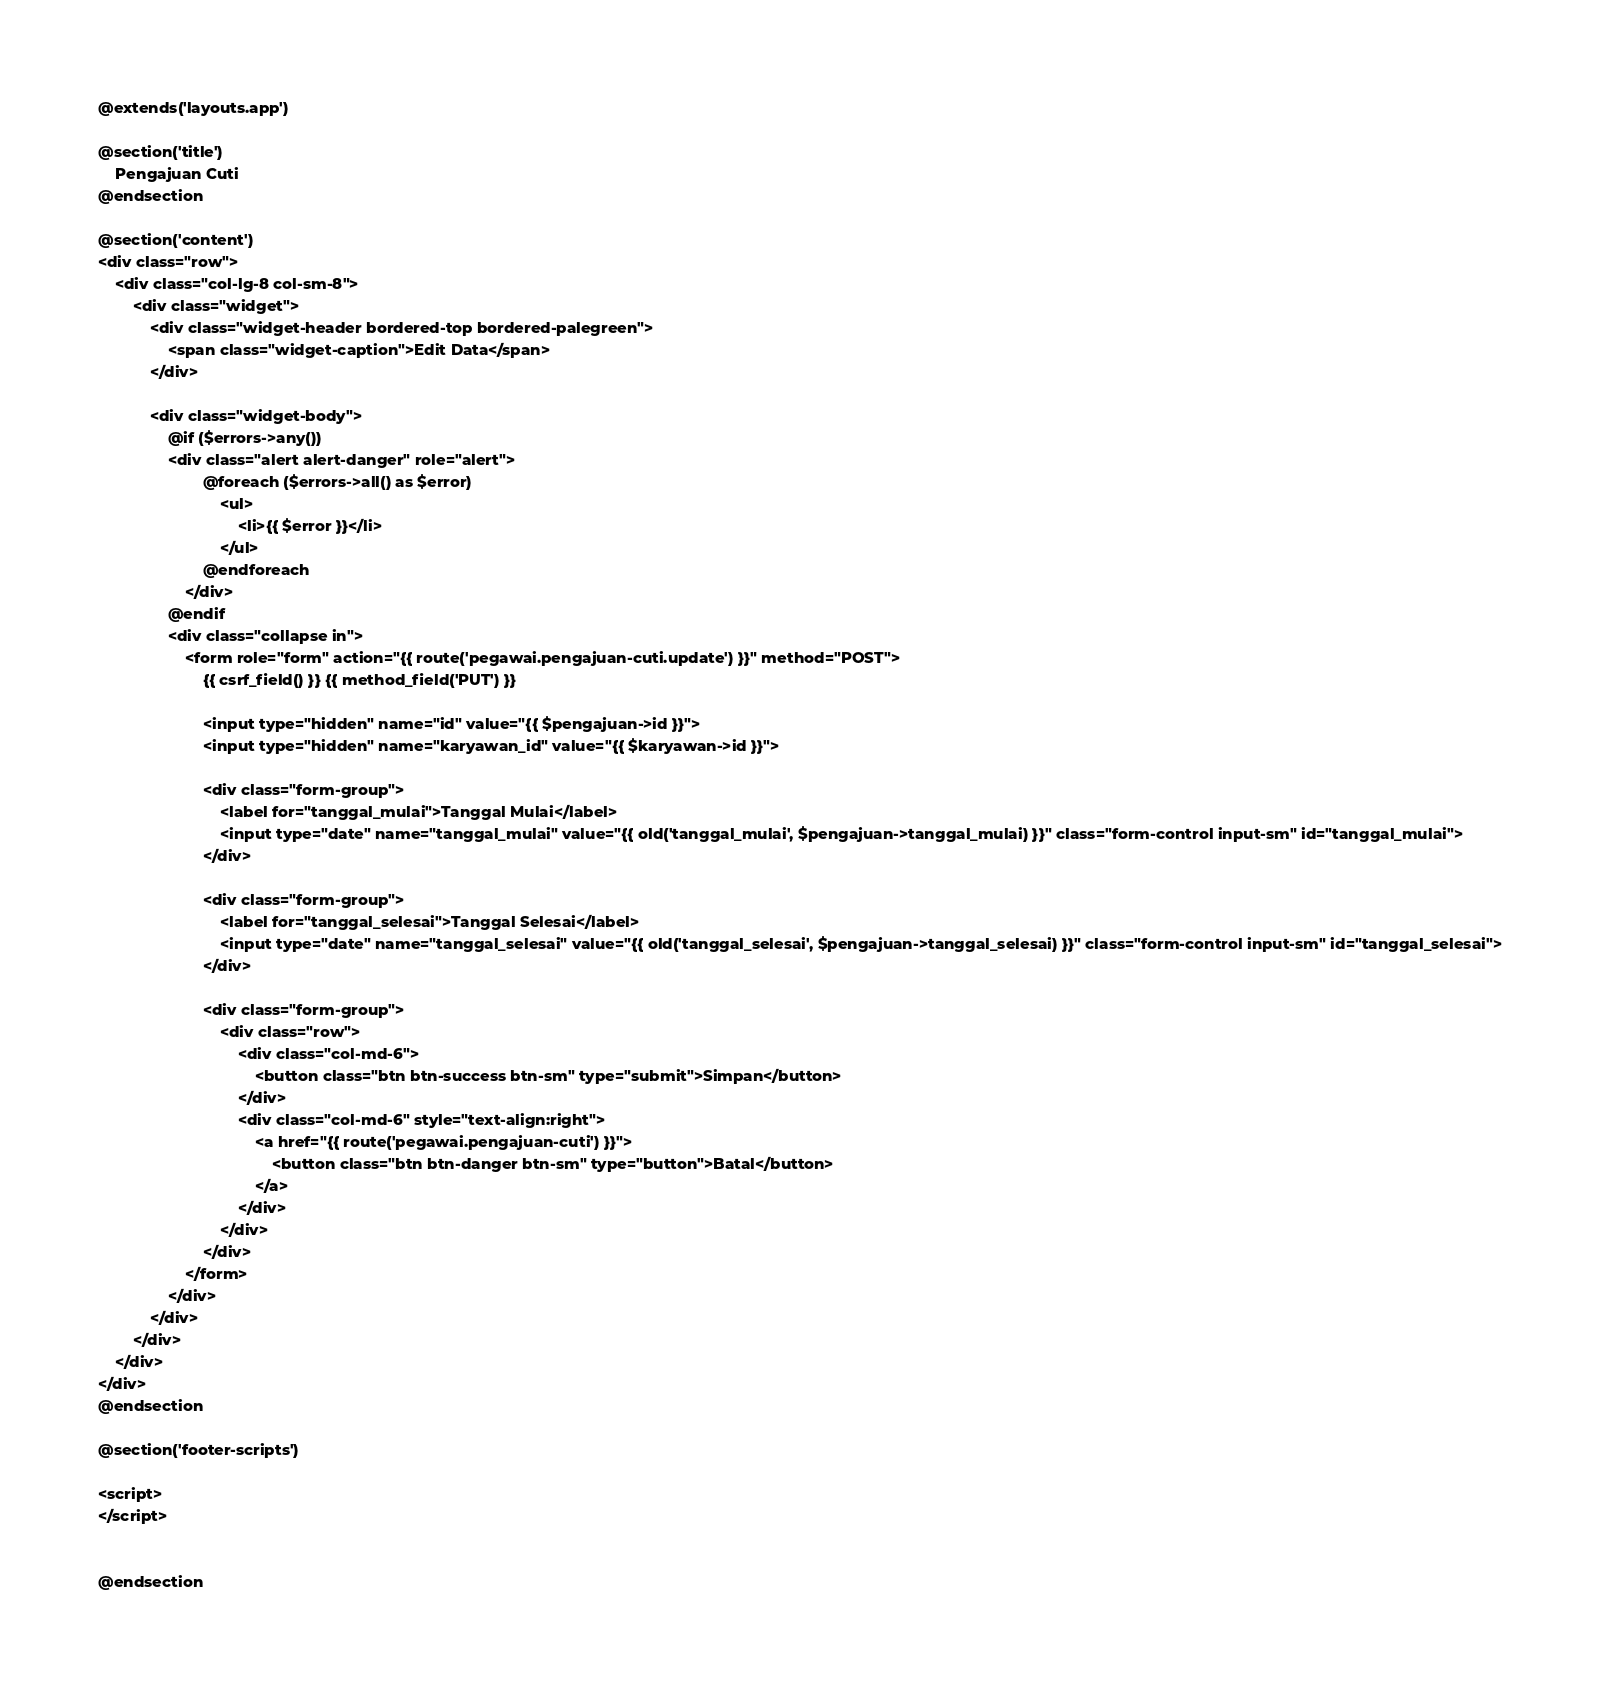<code> <loc_0><loc_0><loc_500><loc_500><_PHP_>@extends('layouts.app')

@section('title')
    Pengajuan Cuti
@endsection

@section('content')
<div class="row">
    <div class="col-lg-8 col-sm-8">
        <div class="widget">
            <div class="widget-header bordered-top bordered-palegreen">
                <span class="widget-caption">Edit Data</span>
            </div>
            
            <div class="widget-body">
                @if ($errors->any())
                <div class="alert alert-danger" role="alert">
                        @foreach ($errors->all() as $error)
                            <ul>
                                <li>{{ $error }}</li>
                            </ul>
                        @endforeach
                    </div>
                @endif
                <div class="collapse in">
                    <form role="form" action="{{ route('pegawai.pengajuan-cuti.update') }}" method="POST">
                        {{ csrf_field() }} {{ method_field('PUT') }}

                        <input type="hidden" name="id" value="{{ $pengajuan->id }}">
                        <input type="hidden" name="karyawan_id" value="{{ $karyawan->id }}">

                        <div class="form-group">
                            <label for="tanggal_mulai">Tanggal Mulai</label>
                            <input type="date" name="tanggal_mulai" value="{{ old('tanggal_mulai', $pengajuan->tanggal_mulai) }}" class="form-control input-sm" id="tanggal_mulai">
                        </div>

                        <div class="form-group">
                            <label for="tanggal_selesai">Tanggal Selesai</label>
                            <input type="date" name="tanggal_selesai" value="{{ old('tanggal_selesai', $pengajuan->tanggal_selesai) }}" class="form-control input-sm" id="tanggal_selesai">
                        </div>

                        <div class="form-group">
                            <div class="row">
                                <div class="col-md-6">
                                    <button class="btn btn-success btn-sm" type="submit">Simpan</button>
                                </div>
                                <div class="col-md-6" style="text-align:right">
                                    <a href="{{ route('pegawai.pengajuan-cuti') }}">
                                        <button class="btn btn-danger btn-sm" type="button">Batal</button>
                                    </a>  
                                </div>
                            </div>
                        </div>
                    </form>
                </div>
            </div>
        </div>
    </div>
</div>
@endsection

@section('footer-scripts')

<script>
</script>  


@endsection</code> 